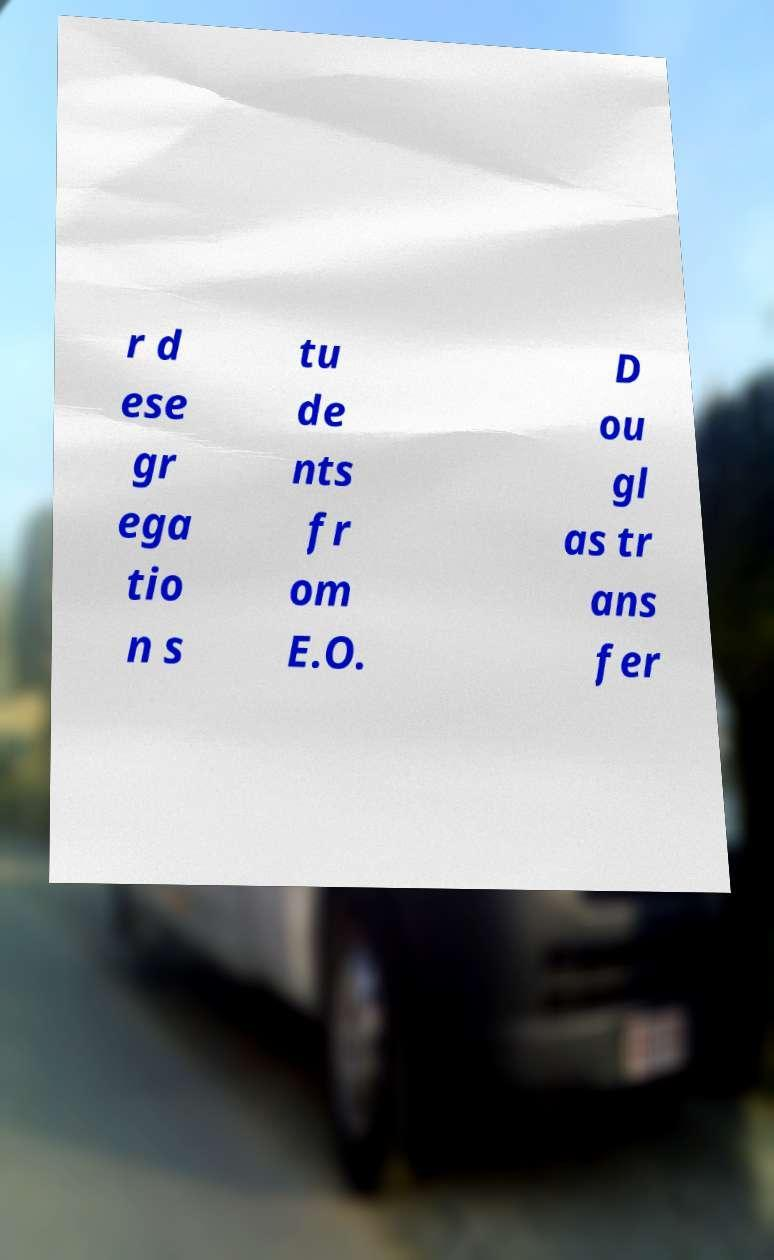Can you read and provide the text displayed in the image?This photo seems to have some interesting text. Can you extract and type it out for me? r d ese gr ega tio n s tu de nts fr om E.O. D ou gl as tr ans fer 